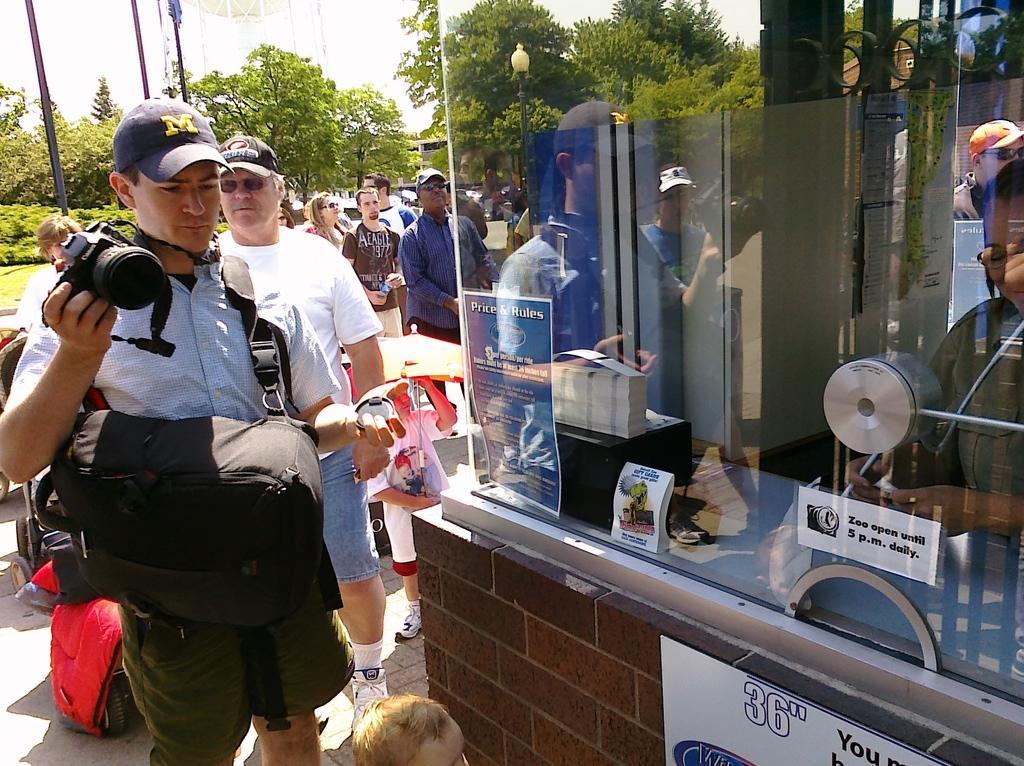Could you give a brief overview of what you see in this image? On the left side of the picture there is a people standing. In the foreground there is a person holding camera and wearing bag. On the right there is a room with glass window, inside the room there is a person. In the background there are trees and poles. It is sunny. 